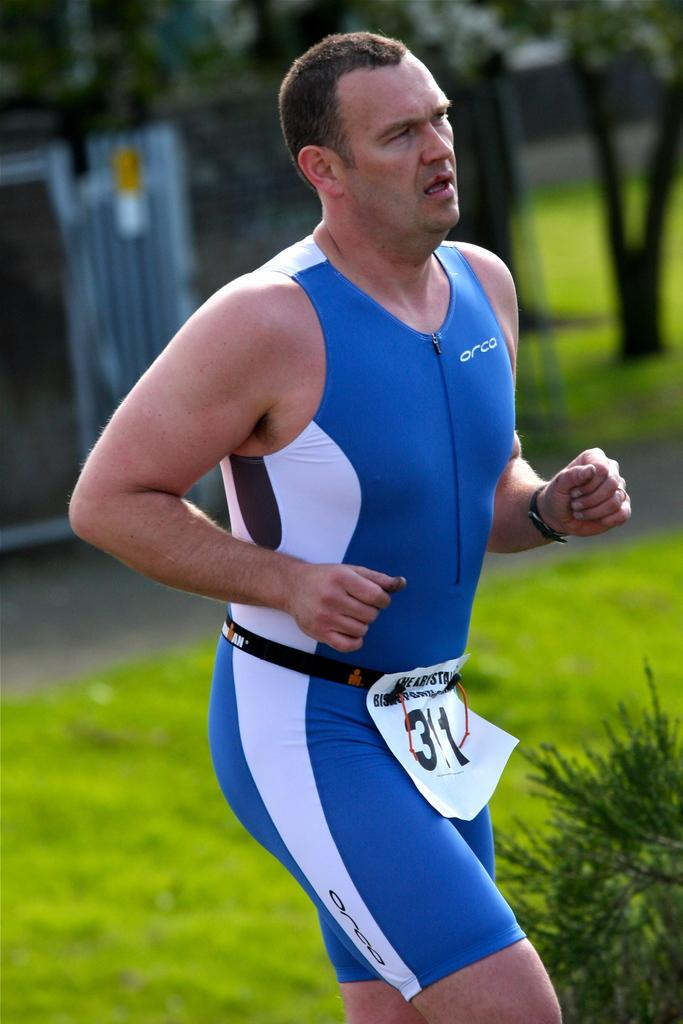<image>
Create a compact narrative representing the image presented. A man in a skintight athletic suit that says Orca is running a marathon. 